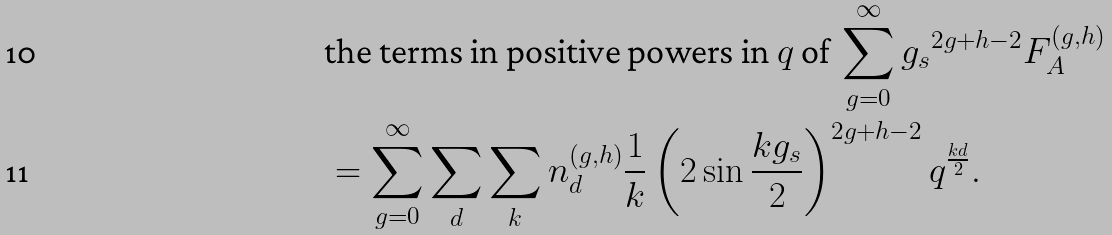Convert formula to latex. <formula><loc_0><loc_0><loc_500><loc_500>& \text {the terms in positive powers in $q$ of } \sum _ { g = 0 } ^ { \infty } { g _ { s } } ^ { 2 g + h - 2 } F _ { A } ^ { ( g , h ) } \\ & = \sum _ { g = 0 } ^ { \infty } \sum _ { d } \sum _ { k } n _ { d } ^ { ( g , h ) } \frac { 1 } { k } \left ( 2 \sin \frac { k g _ { s } } { 2 } \right ) ^ { 2 g + h - 2 } q ^ { \frac { k d } { 2 } } .</formula> 